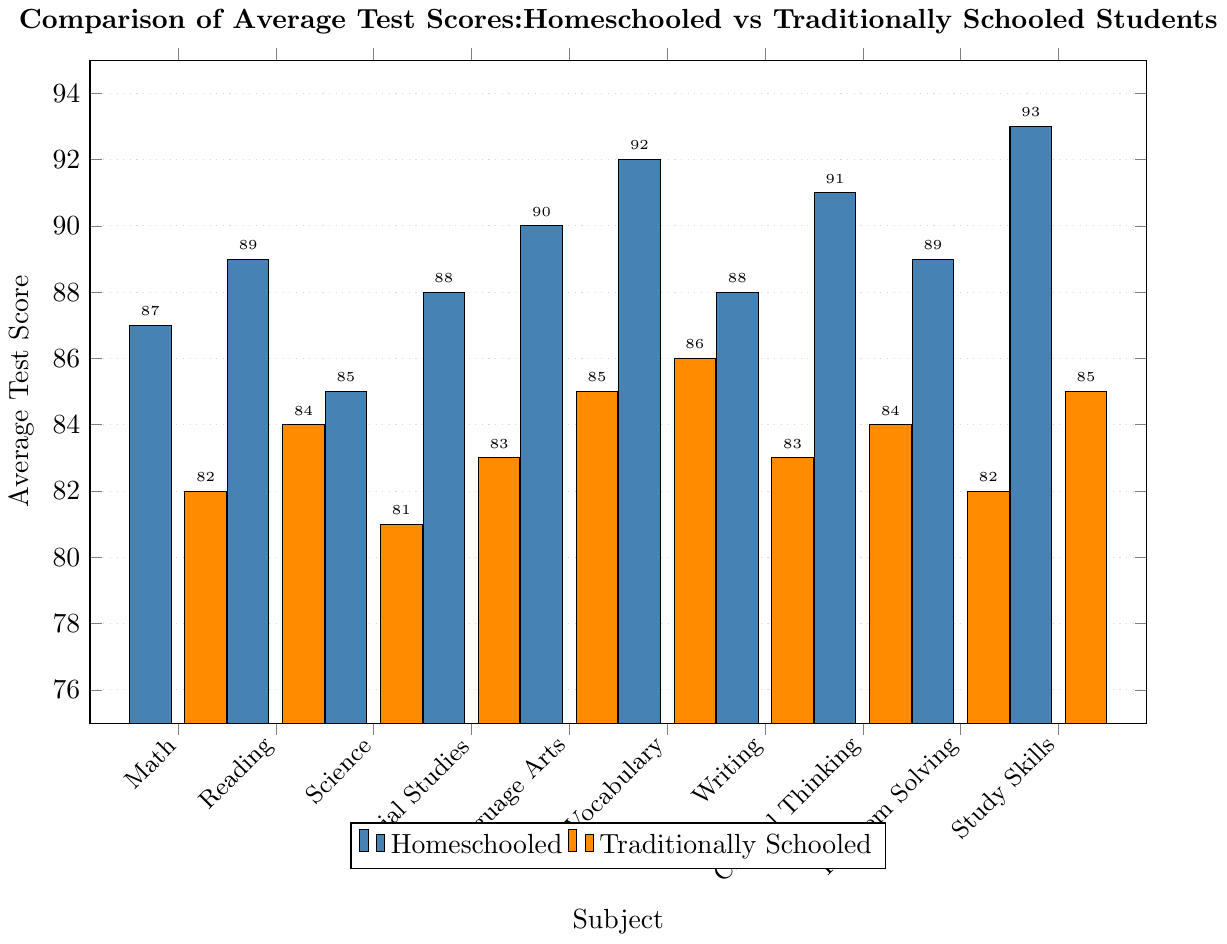What subject shows the highest average test score for homeschooled students? By looking at the bar heights for each subject within the homeschooled category, the highest bar indicates the highest test score. Study Skills has the highest bar with an average score of 93.
Answer: Study Skills How much higher is the average Vocabulary score for homeschooled students compared to traditionally schooled students? Subtract the traditionally schooled average score from the homeschooled average score for Vocabulary. This is 92 - 86 = 6.
Answer: 6 Which subject shows the smallest difference in average test scores between homeschooled and traditionally schooled students? By evaluating the bar heights for each subject, find the smallest difference between homeschooled and traditionally schooled bars. Writing shows the smallest difference, which is 88 - 83 = 5.
Answer: Writing What is the average test score across all subjects for traditionally schooled students? Add all the traditionally schooled scores and divide by the number of subjects: (82 + 84 + 81 + 83 + 85 + 86 + 83 + 84 + 82 + 85) / 10 = 835 / 10 = 83.5.
Answer: 83.5 Which subjects have a higher average score for homeschooled students than traditionally schooled in exactly two units difference? Check each subject to see if the difference between homeschooled and traditionally schooled scores is exactly 2. Science (85 - 81 = 4), Vocabulary (92 - 86 = 6) ... Critical Thinking (91 - 84 = 7) ... Study Skills. No subject has exactly 2 units difference.
Answer: None What's the combined average test score for Reading and Language Arts for homeschooled students? Add the scores for Reading and Language Arts from the homeschooled category and divide by 2: (89 + 90) / 2 = 179 / 2 = 89.5.
Answer: 89.5 